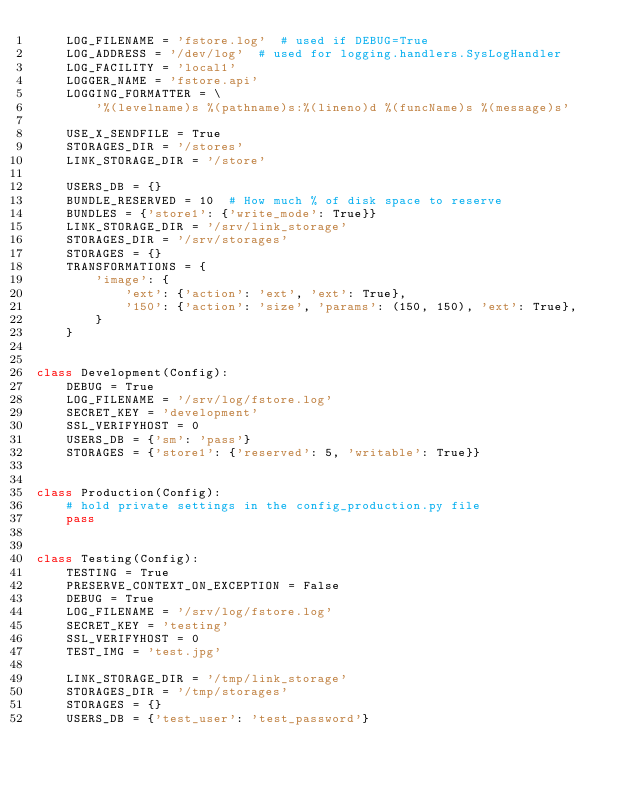Convert code to text. <code><loc_0><loc_0><loc_500><loc_500><_Python_>    LOG_FILENAME = 'fstore.log'  # used if DEBUG=True
    LOG_ADDRESS = '/dev/log'  # used for logging.handlers.SysLogHandler
    LOG_FACILITY = 'local1'
    LOGGER_NAME = 'fstore.api'
    LOGGING_FORMATTER = \
        '%(levelname)s %(pathname)s:%(lineno)d %(funcName)s %(message)s'

    USE_X_SENDFILE = True
    STORAGES_DIR = '/stores'
    LINK_STORAGE_DIR = '/store'

    USERS_DB = {}
    BUNDLE_RESERVED = 10  # How much % of disk space to reserve
    BUNDLES = {'store1': {'write_mode': True}}
    LINK_STORAGE_DIR = '/srv/link_storage'
    STORAGES_DIR = '/srv/storages'
    STORAGES = {}
    TRANSFORMATIONS = {
        'image': {
            'ext': {'action': 'ext', 'ext': True},
            '150': {'action': 'size', 'params': (150, 150), 'ext': True},
        }
    }


class Development(Config):
    DEBUG = True
    LOG_FILENAME = '/srv/log/fstore.log'
    SECRET_KEY = 'development'
    SSL_VERIFYHOST = 0
    USERS_DB = {'sm': 'pass'}
    STORAGES = {'store1': {'reserved': 5, 'writable': True}}


class Production(Config):
    # hold private settings in the config_production.py file
    pass


class Testing(Config):
    TESTING = True
    PRESERVE_CONTEXT_ON_EXCEPTION = False
    DEBUG = True
    LOG_FILENAME = '/srv/log/fstore.log'
    SECRET_KEY = 'testing'
    SSL_VERIFYHOST = 0
    TEST_IMG = 'test.jpg'

    LINK_STORAGE_DIR = '/tmp/link_storage'
    STORAGES_DIR = '/tmp/storages'
    STORAGES = {}
    USERS_DB = {'test_user': 'test_password'}
</code> 